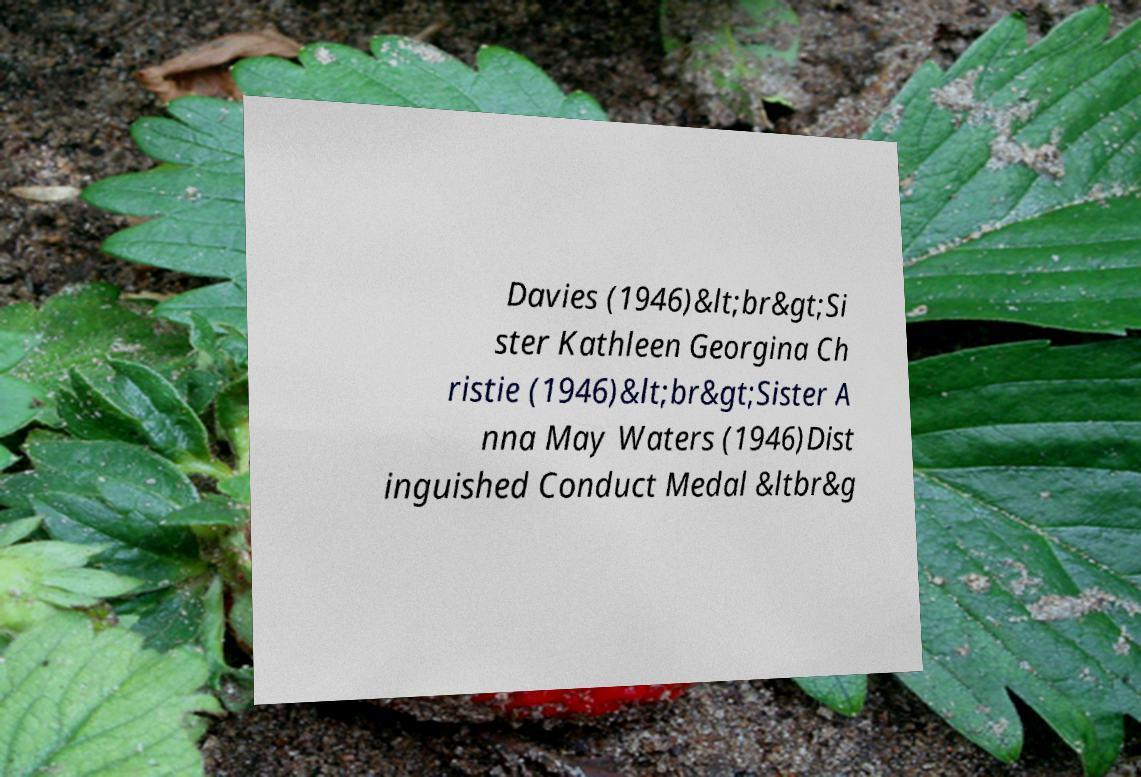Can you accurately transcribe the text from the provided image for me? Davies (1946)&lt;br&gt;Si ster Kathleen Georgina Ch ristie (1946)&lt;br&gt;Sister A nna May Waters (1946)Dist inguished Conduct Medal &ltbr&g 